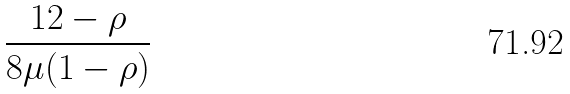Convert formula to latex. <formula><loc_0><loc_0><loc_500><loc_500>\frac { 1 2 - \rho } { 8 \mu ( 1 - \rho ) }</formula> 